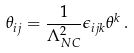<formula> <loc_0><loc_0><loc_500><loc_500>\theta _ { i j } = \frac { 1 } { \Lambda _ { N C } ^ { 2 } } \epsilon _ { i j k } \theta ^ { k } \, .</formula> 